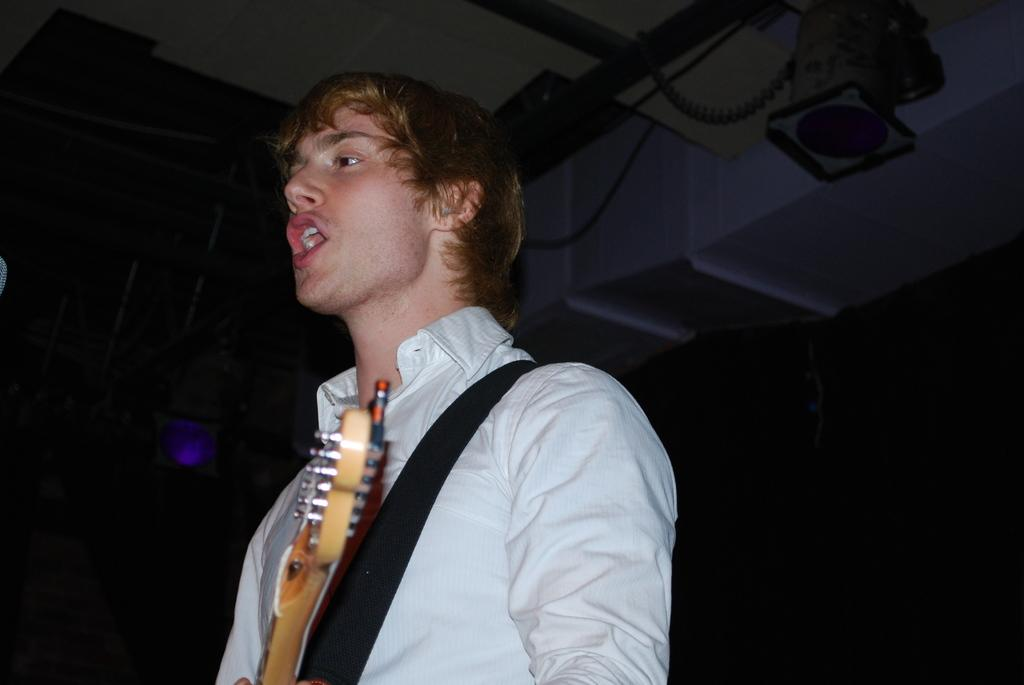What is the man in the image doing? The man is singing in the image. What instrument is the man holding? The man is holding a guitar in the image. What type of clothing is the man wearing on his upper body? The man is wearing a shirt in the image. What type of bait is the man using while singing in the image? There is no bait present in the image; the man is holding a guitar and singing. Is the man wearing a scarf in the image? The provided facts do not mention a scarf, so we cannot determine if the man is wearing one. 